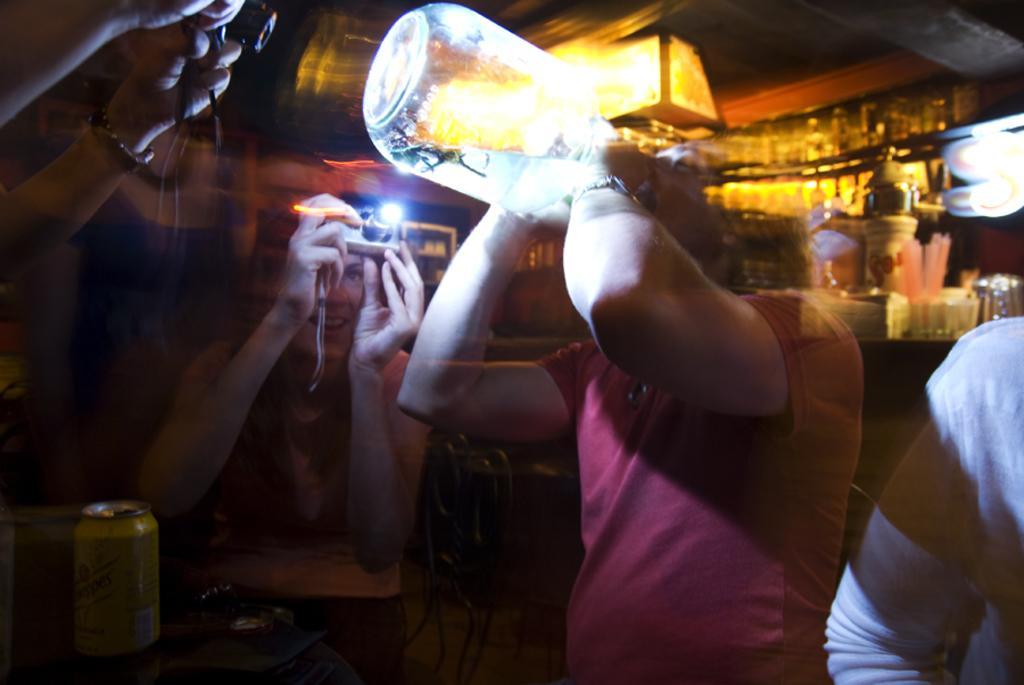Please provide a concise description of this image. In this picture we can see a person who is drinking with the jar. This is tin. And there is a camera. She is taking a snap of this person. These are the chairs. And on the background we can see some bottles in the rack. 